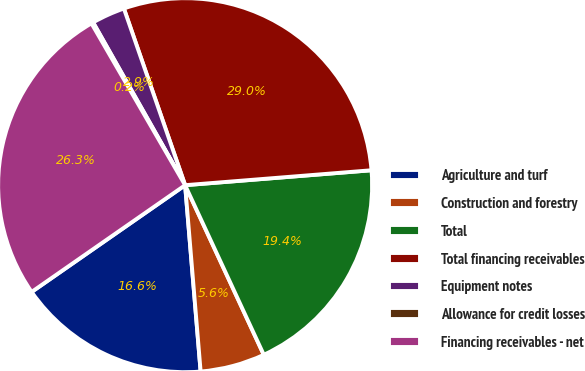Convert chart. <chart><loc_0><loc_0><loc_500><loc_500><pie_chart><fcel>Agriculture and turf<fcel>Construction and forestry<fcel>Total<fcel>Total financing receivables<fcel>Equipment notes<fcel>Allowance for credit losses<fcel>Financing receivables - net<nl><fcel>16.65%<fcel>5.59%<fcel>19.36%<fcel>29.04%<fcel>2.88%<fcel>0.16%<fcel>26.32%<nl></chart> 